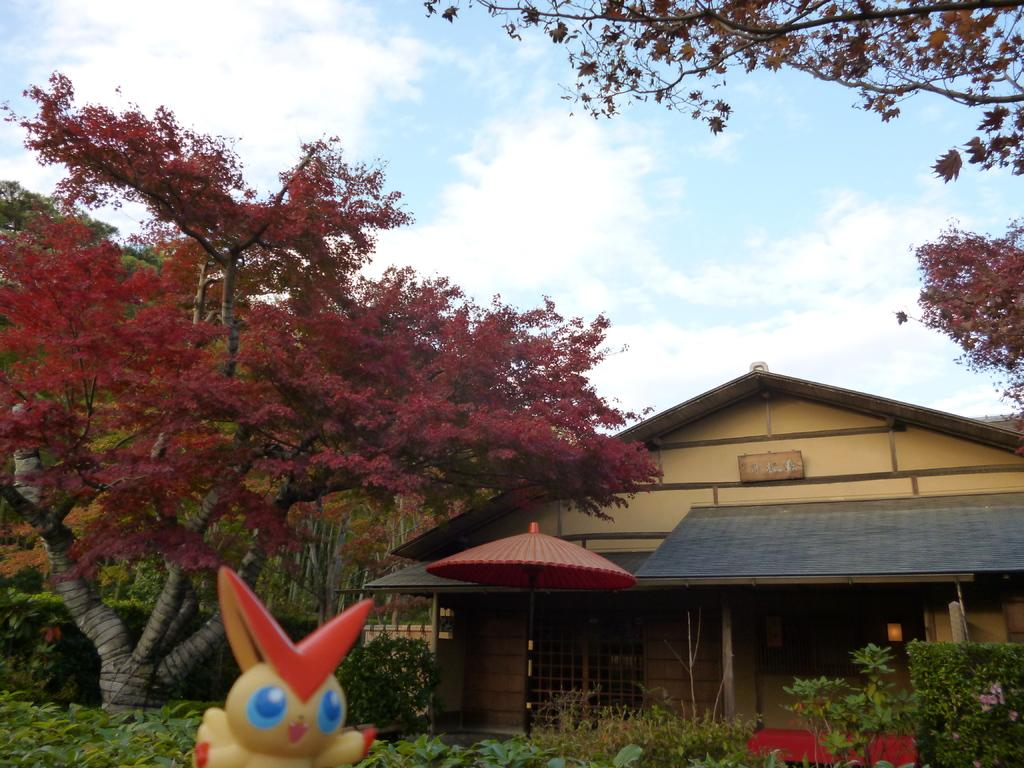What type of structure is present in the image? There is a house in the image. What natural elements can be seen in the image? There are trees and plants in the image. What additional object is present in the image? There is a toy in the image. What object might be used for protection from the rain? There is an umbrella in the image. What is visible in the background of the image? The sky is visible in the background of the image. What type of finger can be seen holding the toy in the image? There are no fingers or hands visible in the image; only the toy is present. 